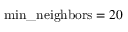<formula> <loc_0><loc_0><loc_500><loc_500>\min \_ n e i g h b o r s = 2 0</formula> 